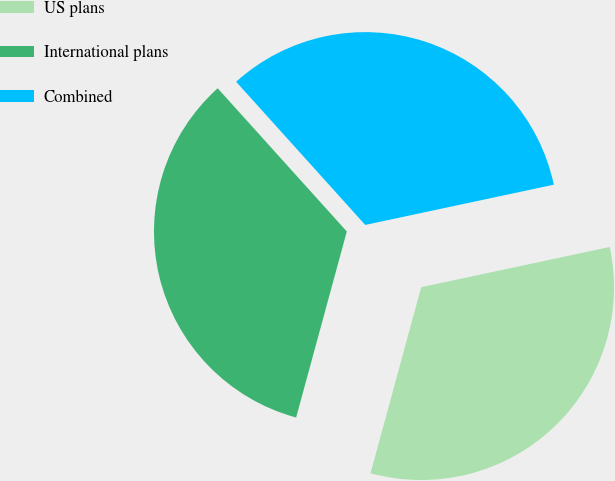<chart> <loc_0><loc_0><loc_500><loc_500><pie_chart><fcel>US plans<fcel>International plans<fcel>Combined<nl><fcel>32.58%<fcel>34.09%<fcel>33.33%<nl></chart> 